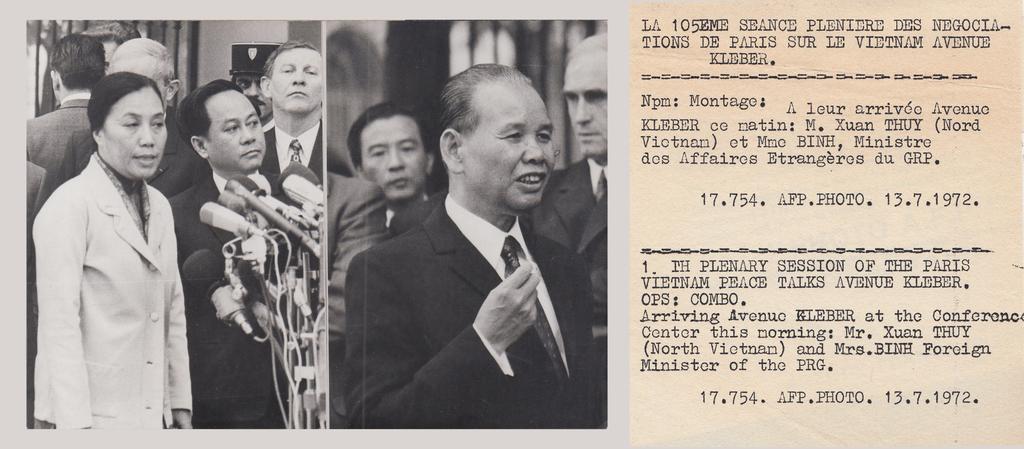In one or two sentences, can you explain what this image depicts? In the left picture there is a woman standing and speaking in front of few mice and there are few persons standing beside her and there is another person standing and speaking and there is few another person standing beside him and there is something written in the right corner. 